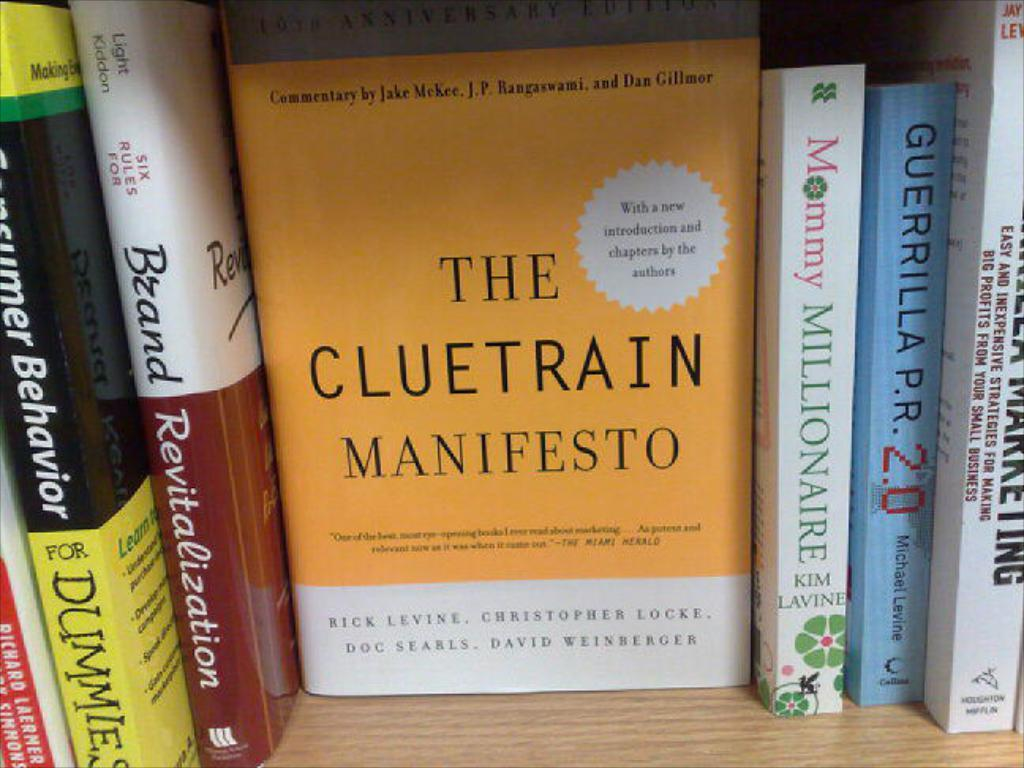<image>
Relay a brief, clear account of the picture shown. The book titled The Cluetrain Manifesto on a shelf in between other books 